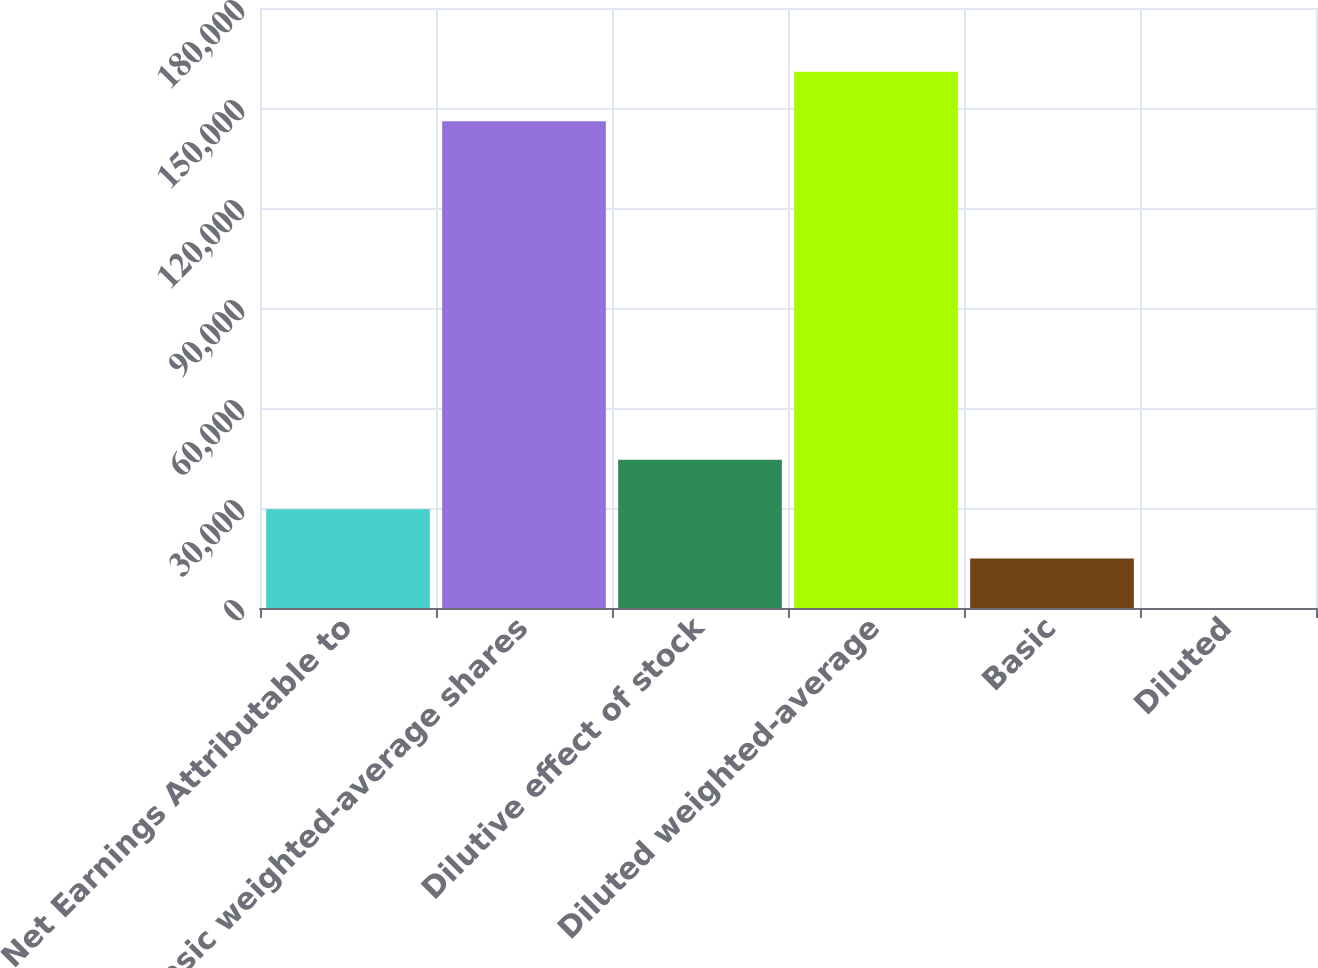<chart> <loc_0><loc_0><loc_500><loc_500><bar_chart><fcel>Net Earnings Attributable to<fcel>Basic weighted-average shares<fcel>Dilutive effect of stock<fcel>Diluted weighted-average<fcel>Basic<fcel>Diluted<nl><fcel>29646.6<fcel>146041<fcel>44466.7<fcel>160861<fcel>14826.6<fcel>6.53<nl></chart> 